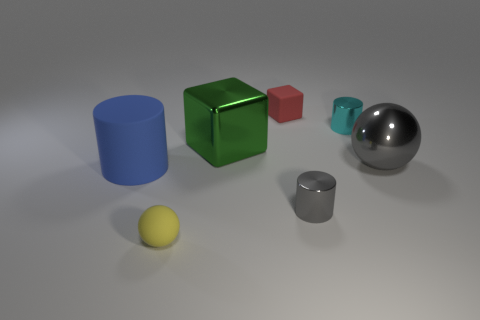Add 2 tiny red things. How many objects exist? 9 Subtract all spheres. How many objects are left? 5 Add 1 big cyan things. How many big cyan things exist? 1 Subtract 1 blue cylinders. How many objects are left? 6 Subtract all tiny gray cylinders. Subtract all yellow matte spheres. How many objects are left? 5 Add 5 cyan things. How many cyan things are left? 6 